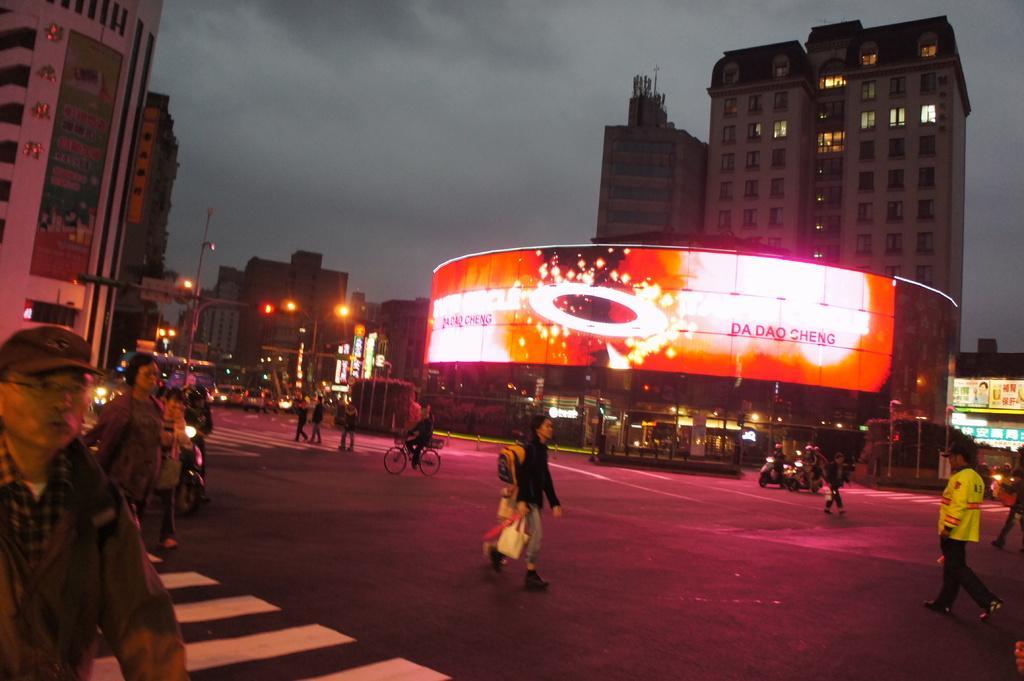How would you summarize this image in a sentence or two? In this image I see the road on which there are number of people and I see a person on this cycle and I see few vehicles. In the background I see the buildings and I see a screen over here on which there is something written and I see the light poles and the traffic signals and I see the sky which is cloudy. 